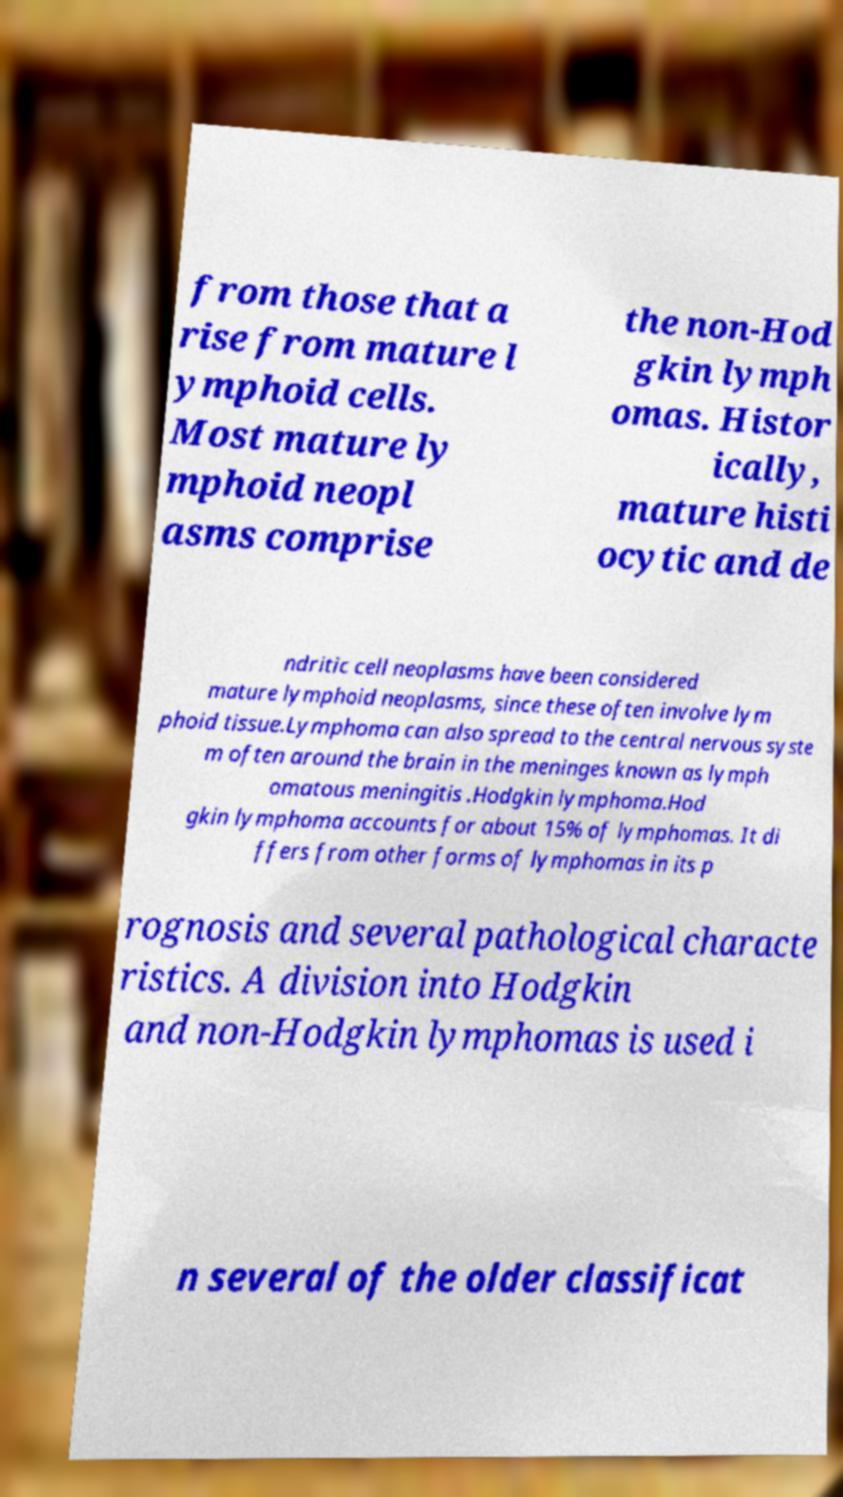Please identify and transcribe the text found in this image. from those that a rise from mature l ymphoid cells. Most mature ly mphoid neopl asms comprise the non-Hod gkin lymph omas. Histor ically, mature histi ocytic and de ndritic cell neoplasms have been considered mature lymphoid neoplasms, since these often involve lym phoid tissue.Lymphoma can also spread to the central nervous syste m often around the brain in the meninges known as lymph omatous meningitis .Hodgkin lymphoma.Hod gkin lymphoma accounts for about 15% of lymphomas. It di ffers from other forms of lymphomas in its p rognosis and several pathological characte ristics. A division into Hodgkin and non-Hodgkin lymphomas is used i n several of the older classificat 